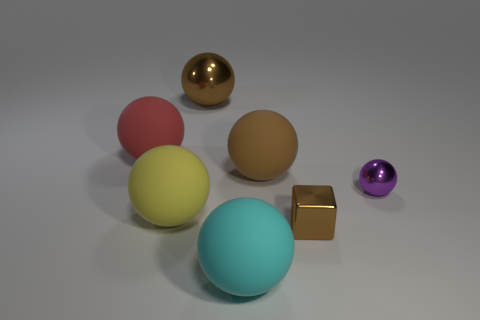Subtract all red spheres. How many spheres are left? 5 Subtract all cyan rubber balls. How many balls are left? 5 Subtract all blue spheres. Subtract all blue cylinders. How many spheres are left? 6 Add 2 big cyan things. How many objects exist? 9 Subtract all balls. How many objects are left? 1 Subtract all small cylinders. Subtract all big red spheres. How many objects are left? 6 Add 5 big brown metal objects. How many big brown metal objects are left? 6 Add 2 yellow spheres. How many yellow spheres exist? 3 Subtract 0 yellow cubes. How many objects are left? 7 